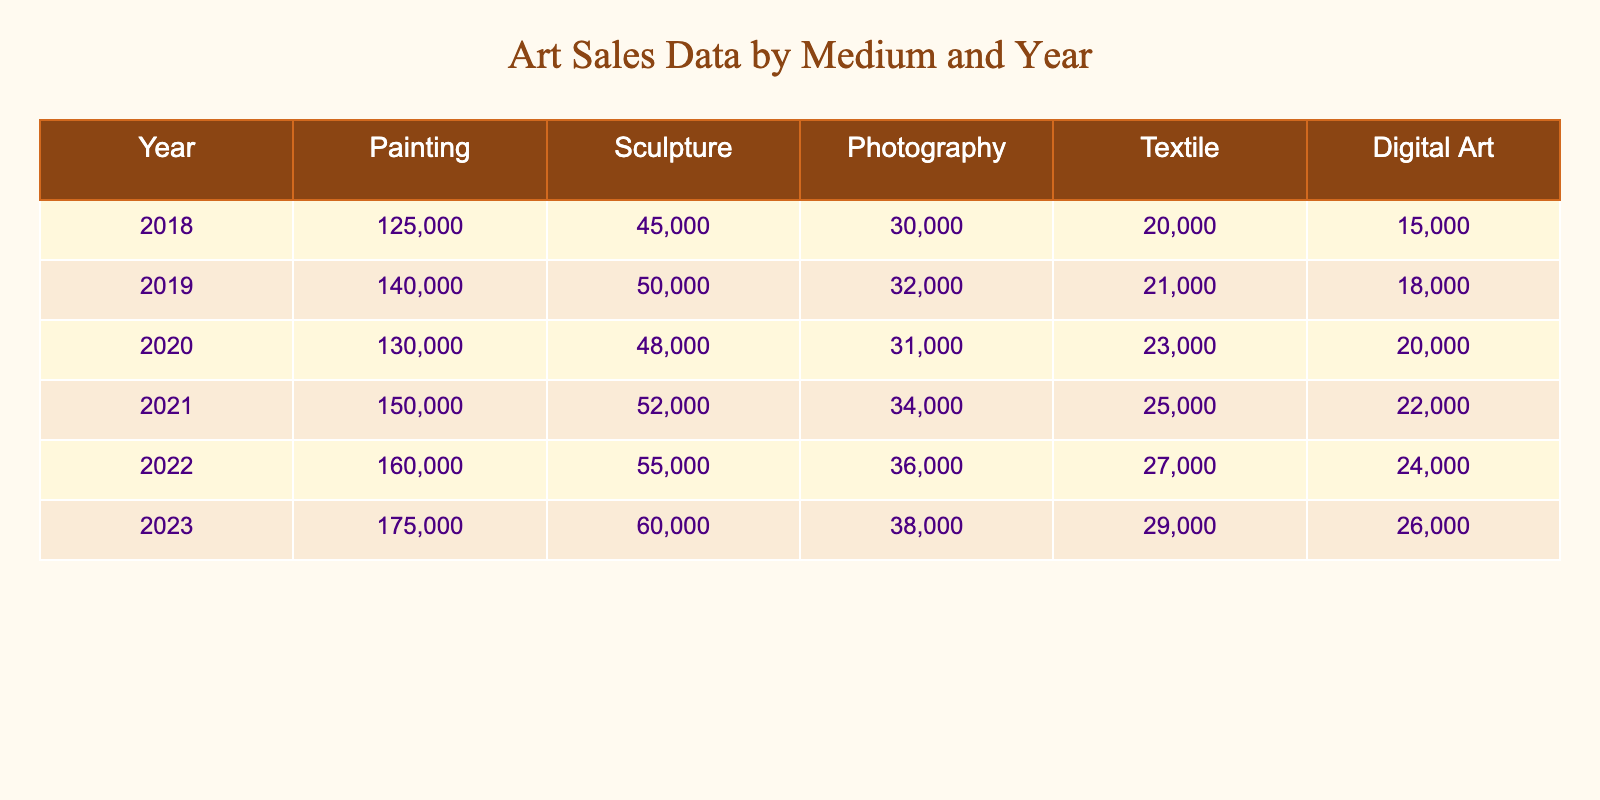What is the total sales value for sculptures in 2021? The sales value for sculptures in 2021 is listed directly in the table as 52000. Thus, the total sales value for sculptures in 2021 is simply 52000.
Answer: 52000 What year had the highest sales value for painting? Looking at the painting sales for each year, the highest value is in 2023, which is 175000. Therefore, 2023 had the highest sales for paintings.
Answer: 2023 What is the average sales value for textile over the years? The textile sales values are 20000, 21000, 23000, 25000, 27000, and 29000. Summing these gives 20000 + 21000 + 23000 + 25000 + 27000 + 29000 = 145000. There are 6 years, so the average is 145000 / 6 = 24166.67 (rounded to two decimal places: 24167).
Answer: 24167 Did the sales for digital art increase every year? By examining the digital art sales from each year, they are as follows: 15000, 18000, 20000, 22000, 24000, 26000. Since each subsequent year shows an increase, the answer is yes, the sales increased every year.
Answer: Yes In which year was the total sales value for all media the highest? To find the year with the highest total sales, we need to calculate the total for each year: 2018 (125000 + 45000 + 30000 + 20000 + 15000 = 220000), 2019 (140000 + 50000 + 32000 + 21000 + 18000 = 237000), 2020 (130000 + 48000 + 31000 + 23000 + 20000 = 228000), 2021 (150000 + 52000 + 34000 + 25000 + 22000 = 285000), 2022 (160000 + 55000 + 36000 + 27000 + 24000 = 288000), and 2023 (175000 + 60000 + 38000 + 29000 + 26000 = 317000). The highest total is in 2023 with 317000.
Answer: 2023 What was the difference in painting sales between 2019 and 2021? The painting sales in 2019 are 140000 and in 2021 they are 150000. The difference is calculated as 150000 - 140000 = 10000.
Answer: 10000 